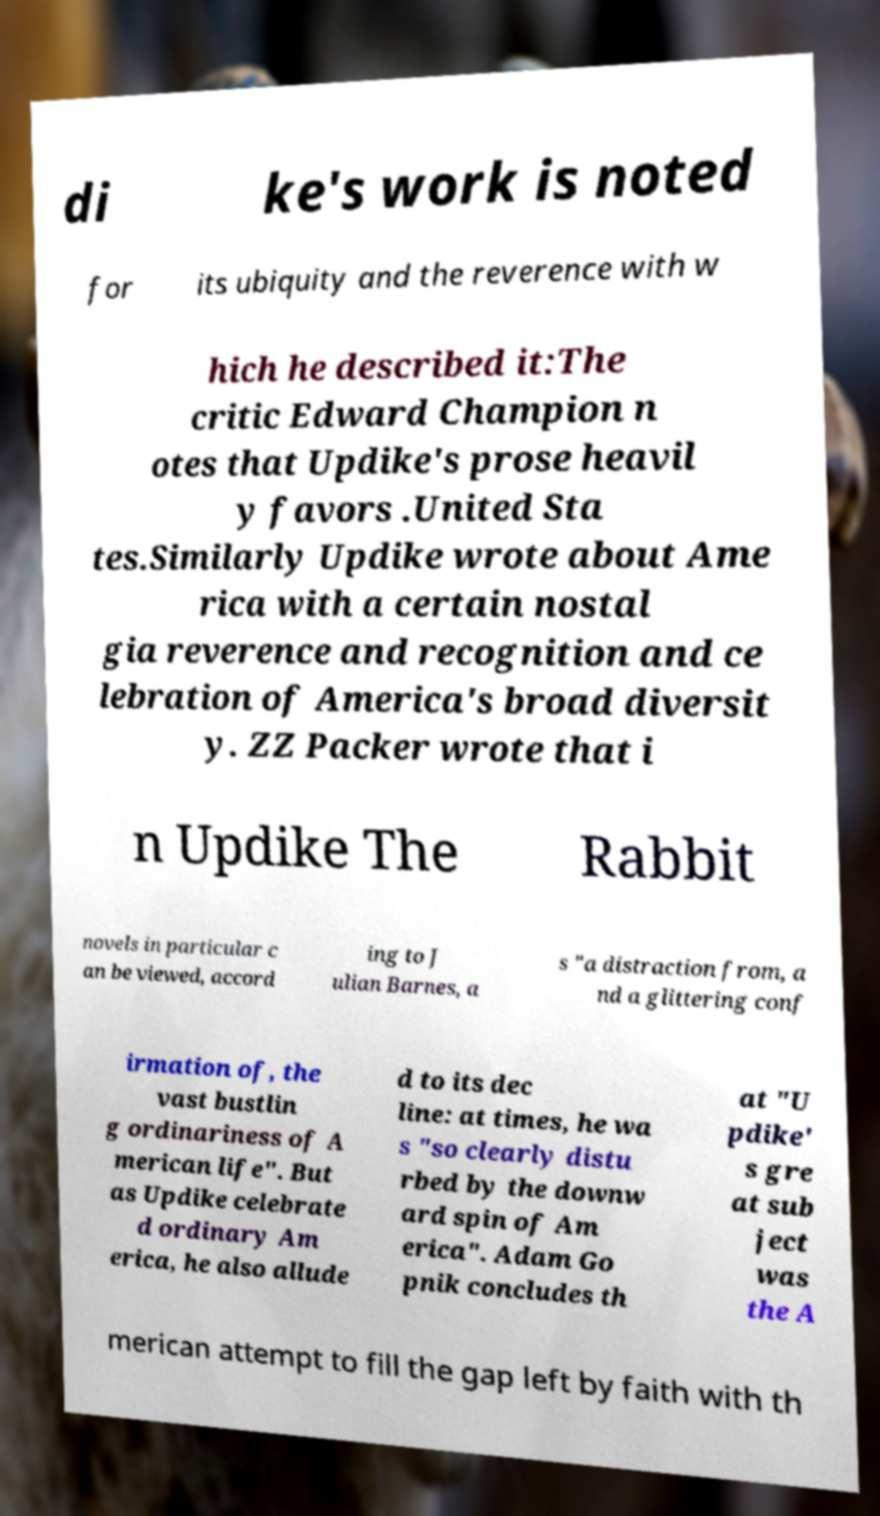Can you read and provide the text displayed in the image?This photo seems to have some interesting text. Can you extract and type it out for me? di ke's work is noted for its ubiquity and the reverence with w hich he described it:The critic Edward Champion n otes that Updike's prose heavil y favors .United Sta tes.Similarly Updike wrote about Ame rica with a certain nostal gia reverence and recognition and ce lebration of America's broad diversit y. ZZ Packer wrote that i n Updike The Rabbit novels in particular c an be viewed, accord ing to J ulian Barnes, a s "a distraction from, a nd a glittering conf irmation of, the vast bustlin g ordinariness of A merican life". But as Updike celebrate d ordinary Am erica, he also allude d to its dec line: at times, he wa s "so clearly distu rbed by the downw ard spin of Am erica". Adam Go pnik concludes th at "U pdike' s gre at sub ject was the A merican attempt to fill the gap left by faith with th 